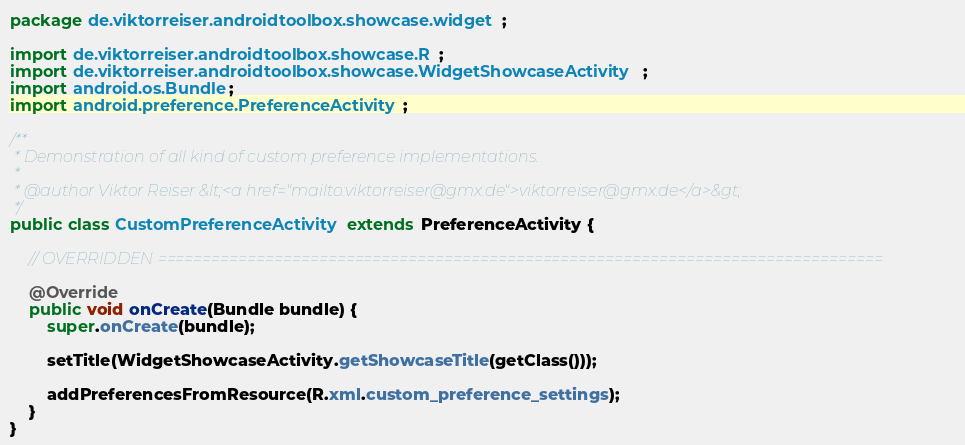Convert code to text. <code><loc_0><loc_0><loc_500><loc_500><_Java_>package de.viktorreiser.androidtoolbox.showcase.widget;

import de.viktorreiser.androidtoolbox.showcase.R;
import de.viktorreiser.androidtoolbox.showcase.WidgetShowcaseActivity;
import android.os.Bundle;
import android.preference.PreferenceActivity;

/**
 * Demonstration of all kind of custom preference implementations.
 * 
 * @author Viktor Reiser &lt;<a href="mailto:viktorreiser@gmx.de">viktorreiser@gmx.de</a>&gt;
 */
public class CustomPreferenceActivity extends PreferenceActivity {
	
	// OVERRIDDEN =================================================================================
	
	@Override
	public void onCreate(Bundle bundle) {
		super.onCreate(bundle);
		
		setTitle(WidgetShowcaseActivity.getShowcaseTitle(getClass()));
		
		addPreferencesFromResource(R.xml.custom_preference_settings);
	}
}
</code> 